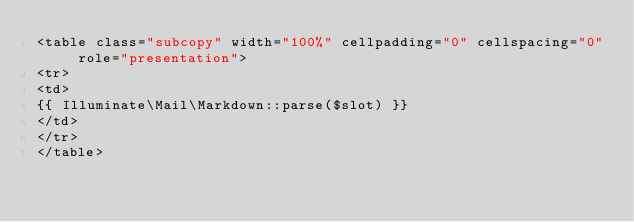Convert code to text. <code><loc_0><loc_0><loc_500><loc_500><_PHP_><table class="subcopy" width="100%" cellpadding="0" cellspacing="0" role="presentation">
<tr>
<td>
{{ Illuminate\Mail\Markdown::parse($slot) }}
</td>
</tr>
</table>
</code> 